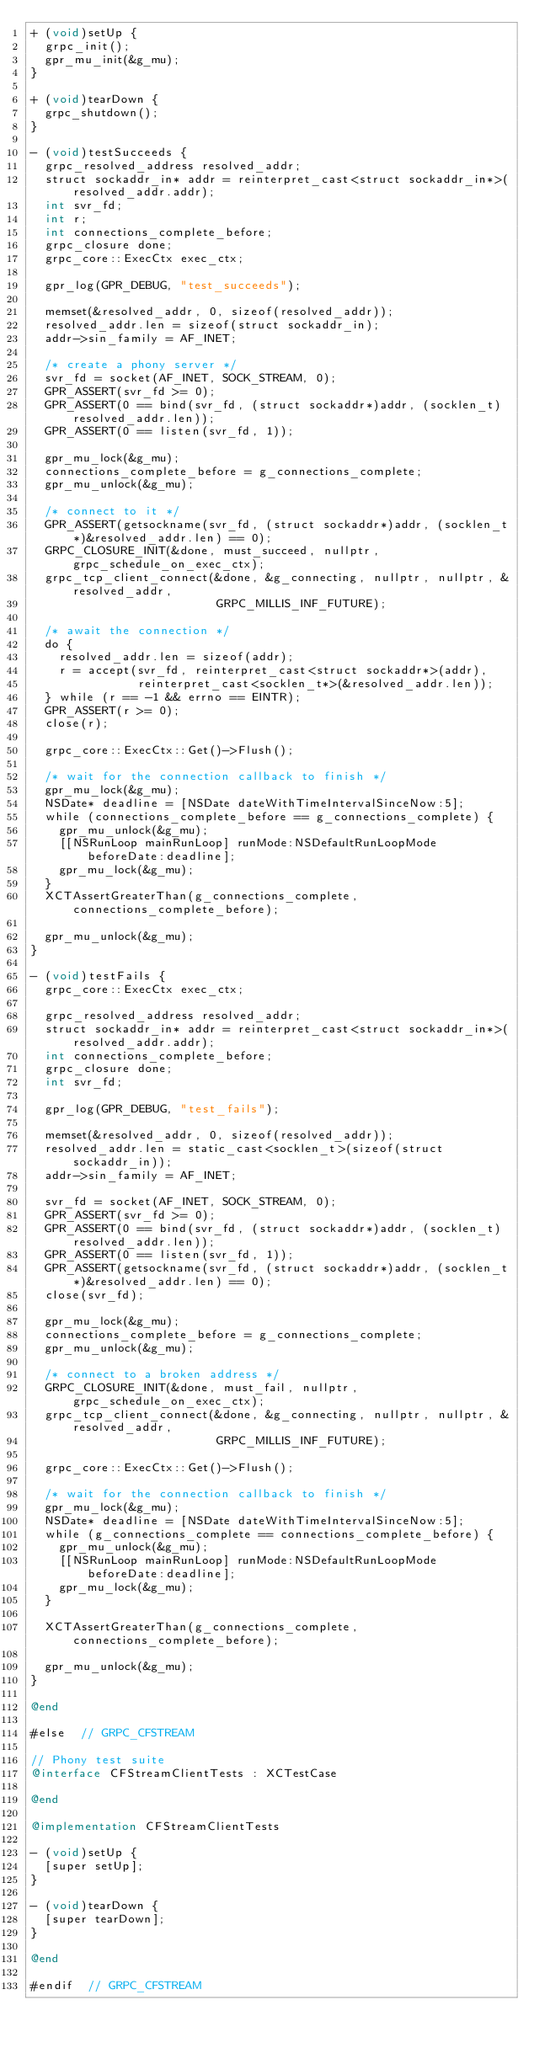Convert code to text. <code><loc_0><loc_0><loc_500><loc_500><_ObjectiveC_>+ (void)setUp {
  grpc_init();
  gpr_mu_init(&g_mu);
}

+ (void)tearDown {
  grpc_shutdown();
}

- (void)testSucceeds {
  grpc_resolved_address resolved_addr;
  struct sockaddr_in* addr = reinterpret_cast<struct sockaddr_in*>(resolved_addr.addr);
  int svr_fd;
  int r;
  int connections_complete_before;
  grpc_closure done;
  grpc_core::ExecCtx exec_ctx;

  gpr_log(GPR_DEBUG, "test_succeeds");

  memset(&resolved_addr, 0, sizeof(resolved_addr));
  resolved_addr.len = sizeof(struct sockaddr_in);
  addr->sin_family = AF_INET;

  /* create a phony server */
  svr_fd = socket(AF_INET, SOCK_STREAM, 0);
  GPR_ASSERT(svr_fd >= 0);
  GPR_ASSERT(0 == bind(svr_fd, (struct sockaddr*)addr, (socklen_t)resolved_addr.len));
  GPR_ASSERT(0 == listen(svr_fd, 1));

  gpr_mu_lock(&g_mu);
  connections_complete_before = g_connections_complete;
  gpr_mu_unlock(&g_mu);

  /* connect to it */
  GPR_ASSERT(getsockname(svr_fd, (struct sockaddr*)addr, (socklen_t*)&resolved_addr.len) == 0);
  GRPC_CLOSURE_INIT(&done, must_succeed, nullptr, grpc_schedule_on_exec_ctx);
  grpc_tcp_client_connect(&done, &g_connecting, nullptr, nullptr, &resolved_addr,
                          GRPC_MILLIS_INF_FUTURE);

  /* await the connection */
  do {
    resolved_addr.len = sizeof(addr);
    r = accept(svr_fd, reinterpret_cast<struct sockaddr*>(addr),
               reinterpret_cast<socklen_t*>(&resolved_addr.len));
  } while (r == -1 && errno == EINTR);
  GPR_ASSERT(r >= 0);
  close(r);

  grpc_core::ExecCtx::Get()->Flush();

  /* wait for the connection callback to finish */
  gpr_mu_lock(&g_mu);
  NSDate* deadline = [NSDate dateWithTimeIntervalSinceNow:5];
  while (connections_complete_before == g_connections_complete) {
    gpr_mu_unlock(&g_mu);
    [[NSRunLoop mainRunLoop] runMode:NSDefaultRunLoopMode beforeDate:deadline];
    gpr_mu_lock(&g_mu);
  }
  XCTAssertGreaterThan(g_connections_complete, connections_complete_before);

  gpr_mu_unlock(&g_mu);
}

- (void)testFails {
  grpc_core::ExecCtx exec_ctx;

  grpc_resolved_address resolved_addr;
  struct sockaddr_in* addr = reinterpret_cast<struct sockaddr_in*>(resolved_addr.addr);
  int connections_complete_before;
  grpc_closure done;
  int svr_fd;

  gpr_log(GPR_DEBUG, "test_fails");

  memset(&resolved_addr, 0, sizeof(resolved_addr));
  resolved_addr.len = static_cast<socklen_t>(sizeof(struct sockaddr_in));
  addr->sin_family = AF_INET;

  svr_fd = socket(AF_INET, SOCK_STREAM, 0);
  GPR_ASSERT(svr_fd >= 0);
  GPR_ASSERT(0 == bind(svr_fd, (struct sockaddr*)addr, (socklen_t)resolved_addr.len));
  GPR_ASSERT(0 == listen(svr_fd, 1));
  GPR_ASSERT(getsockname(svr_fd, (struct sockaddr*)addr, (socklen_t*)&resolved_addr.len) == 0);
  close(svr_fd);

  gpr_mu_lock(&g_mu);
  connections_complete_before = g_connections_complete;
  gpr_mu_unlock(&g_mu);

  /* connect to a broken address */
  GRPC_CLOSURE_INIT(&done, must_fail, nullptr, grpc_schedule_on_exec_ctx);
  grpc_tcp_client_connect(&done, &g_connecting, nullptr, nullptr, &resolved_addr,
                          GRPC_MILLIS_INF_FUTURE);

  grpc_core::ExecCtx::Get()->Flush();

  /* wait for the connection callback to finish */
  gpr_mu_lock(&g_mu);
  NSDate* deadline = [NSDate dateWithTimeIntervalSinceNow:5];
  while (g_connections_complete == connections_complete_before) {
    gpr_mu_unlock(&g_mu);
    [[NSRunLoop mainRunLoop] runMode:NSDefaultRunLoopMode beforeDate:deadline];
    gpr_mu_lock(&g_mu);
  }

  XCTAssertGreaterThan(g_connections_complete, connections_complete_before);

  gpr_mu_unlock(&g_mu);
}

@end

#else  // GRPC_CFSTREAM

// Phony test suite
@interface CFStreamClientTests : XCTestCase

@end

@implementation CFStreamClientTests

- (void)setUp {
  [super setUp];
}

- (void)tearDown {
  [super tearDown];
}

@end

#endif  // GRPC_CFSTREAM
</code> 